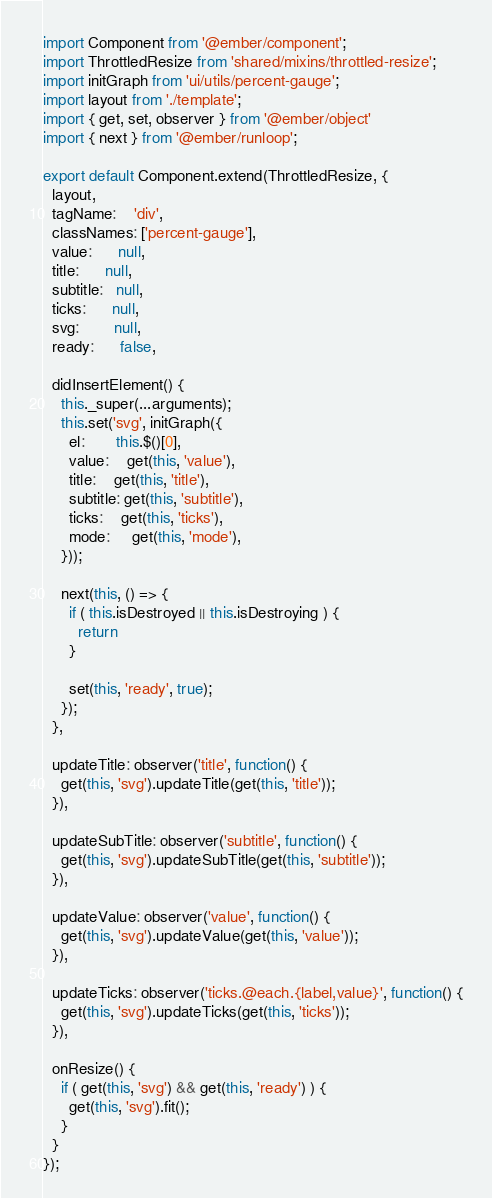<code> <loc_0><loc_0><loc_500><loc_500><_JavaScript_>import Component from '@ember/component';
import ThrottledResize from 'shared/mixins/throttled-resize';
import initGraph from 'ui/utils/percent-gauge';
import layout from './template';
import { get, set, observer } from '@ember/object'
import { next } from '@ember/runloop';

export default Component.extend(ThrottledResize, {
  layout,
  tagName:    'div',
  classNames: ['percent-gauge'],
  value:      null,
  title:      null,
  subtitle:   null,
  ticks:      null,
  svg:        null,
  ready:      false,

  didInsertElement() {
    this._super(...arguments);
    this.set('svg', initGraph({
      el:       this.$()[0],
      value:    get(this, 'value'),
      title:    get(this, 'title'),
      subtitle: get(this, 'subtitle'),
      ticks:    get(this, 'ticks'),
      mode:     get(this, 'mode'),
    }));

    next(this, () => {
      if ( this.isDestroyed || this.isDestroying ) {
        return
      }

      set(this, 'ready', true);
    });
  },

  updateTitle: observer('title', function() {
    get(this, 'svg').updateTitle(get(this, 'title'));
  }),

  updateSubTitle: observer('subtitle', function() {
    get(this, 'svg').updateSubTitle(get(this, 'subtitle'));
  }),

  updateValue: observer('value', function() {
    get(this, 'svg').updateValue(get(this, 'value'));
  }),

  updateTicks: observer('ticks.@each.{label,value}', function() {
    get(this, 'svg').updateTicks(get(this, 'ticks'));
  }),

  onResize() {
    if ( get(this, 'svg') && get(this, 'ready') ) {
      get(this, 'svg').fit();
    }
  }
});
</code> 